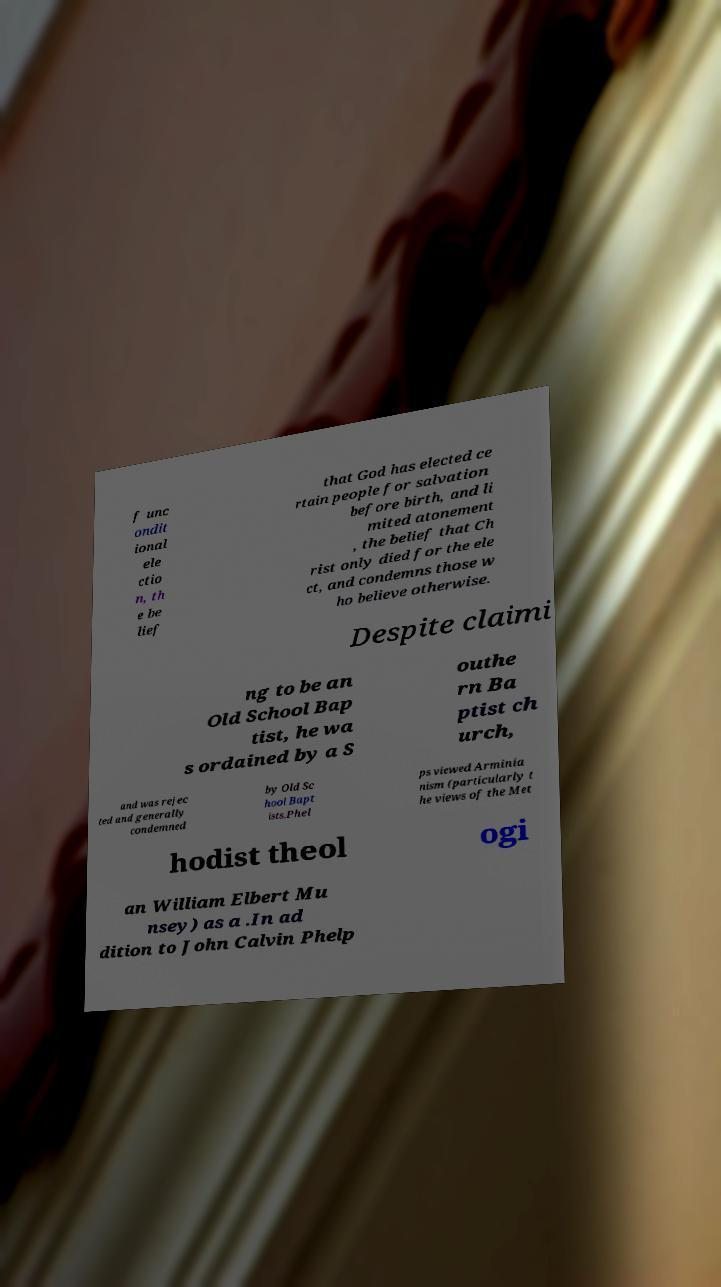There's text embedded in this image that I need extracted. Can you transcribe it verbatim? f unc ondit ional ele ctio n, th e be lief that God has elected ce rtain people for salvation before birth, and li mited atonement , the belief that Ch rist only died for the ele ct, and condemns those w ho believe otherwise. Despite claimi ng to be an Old School Bap tist, he wa s ordained by a S outhe rn Ba ptist ch urch, and was rejec ted and generally condemned by Old Sc hool Bapt ists.Phel ps viewed Arminia nism (particularly t he views of the Met hodist theol ogi an William Elbert Mu nsey) as a .In ad dition to John Calvin Phelp 